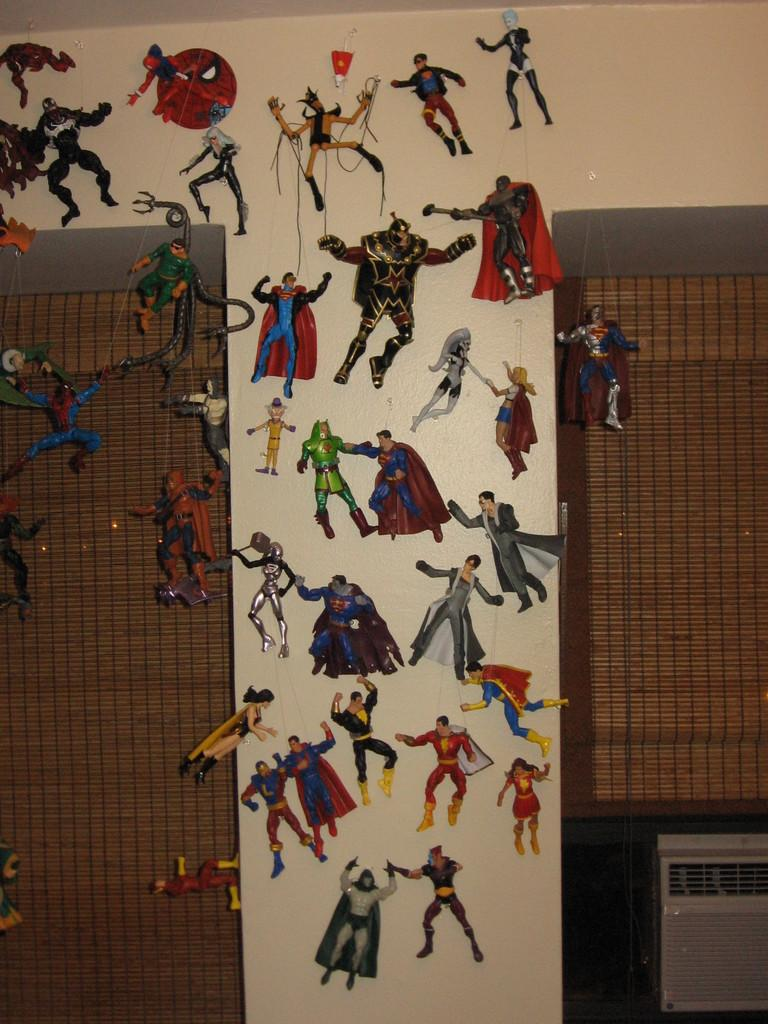What is attached to the wall in the image? There are stickers placed on the wall in the image. What type of window treatment is present in the image? There are curtains in the image. What type of holiday is depicted on the stickers in the image? There is no indication of a holiday on the stickers in the image. Can you see a plane flying in the image? There is no plane visible in the image. 